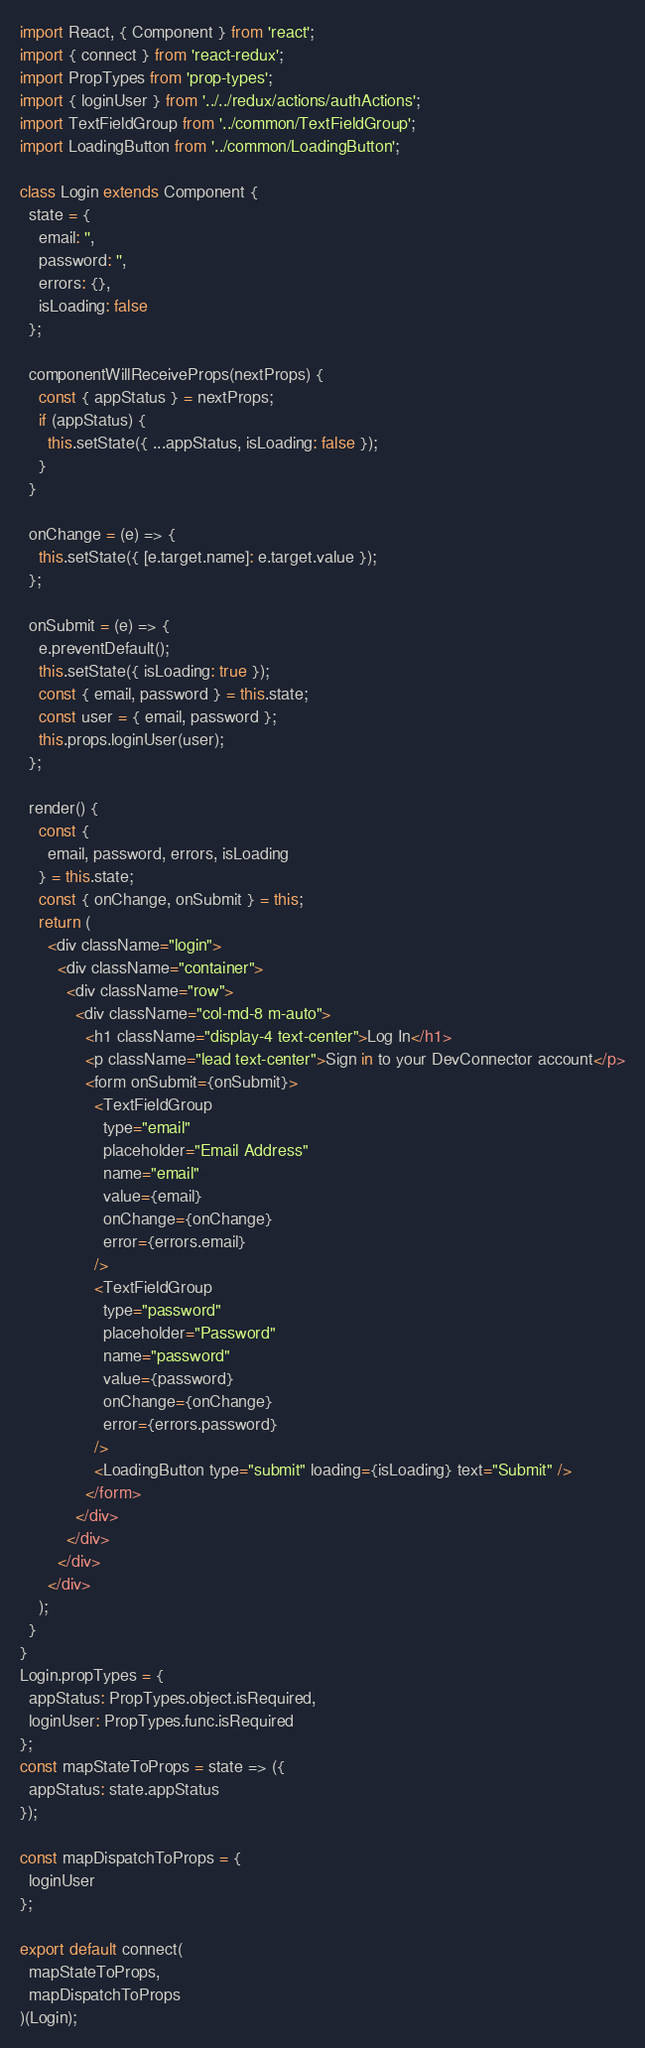<code> <loc_0><loc_0><loc_500><loc_500><_JavaScript_>import React, { Component } from 'react';
import { connect } from 'react-redux';
import PropTypes from 'prop-types';
import { loginUser } from '../../redux/actions/authActions';
import TextFieldGroup from '../common/TextFieldGroup';
import LoadingButton from '../common/LoadingButton';

class Login extends Component {
  state = {
    email: '',
    password: '',
    errors: {},
    isLoading: false
  };

  componentWillReceiveProps(nextProps) {
    const { appStatus } = nextProps;
    if (appStatus) {
      this.setState({ ...appStatus, isLoading: false });
    }
  }

  onChange = (e) => {
    this.setState({ [e.target.name]: e.target.value });
  };

  onSubmit = (e) => {
    e.preventDefault();
    this.setState({ isLoading: true });
    const { email, password } = this.state;
    const user = { email, password };
    this.props.loginUser(user);
  };

  render() {
    const {
      email, password, errors, isLoading
    } = this.state;
    const { onChange, onSubmit } = this;
    return (
      <div className="login">
        <div className="container">
          <div className="row">
            <div className="col-md-8 m-auto">
              <h1 className="display-4 text-center">Log In</h1>
              <p className="lead text-center">Sign in to your DevConnector account</p>
              <form onSubmit={onSubmit}>
                <TextFieldGroup
                  type="email"
                  placeholder="Email Address"
                  name="email"
                  value={email}
                  onChange={onChange}
                  error={errors.email}
                />
                <TextFieldGroup
                  type="password"
                  placeholder="Password"
                  name="password"
                  value={password}
                  onChange={onChange}
                  error={errors.password}
                />
                <LoadingButton type="submit" loading={isLoading} text="Submit" />
              </form>
            </div>
          </div>
        </div>
      </div>
    );
  }
}
Login.propTypes = {
  appStatus: PropTypes.object.isRequired,
  loginUser: PropTypes.func.isRequired
};
const mapStateToProps = state => ({
  appStatus: state.appStatus
});

const mapDispatchToProps = {
  loginUser
};

export default connect(
  mapStateToProps,
  mapDispatchToProps
)(Login);
</code> 